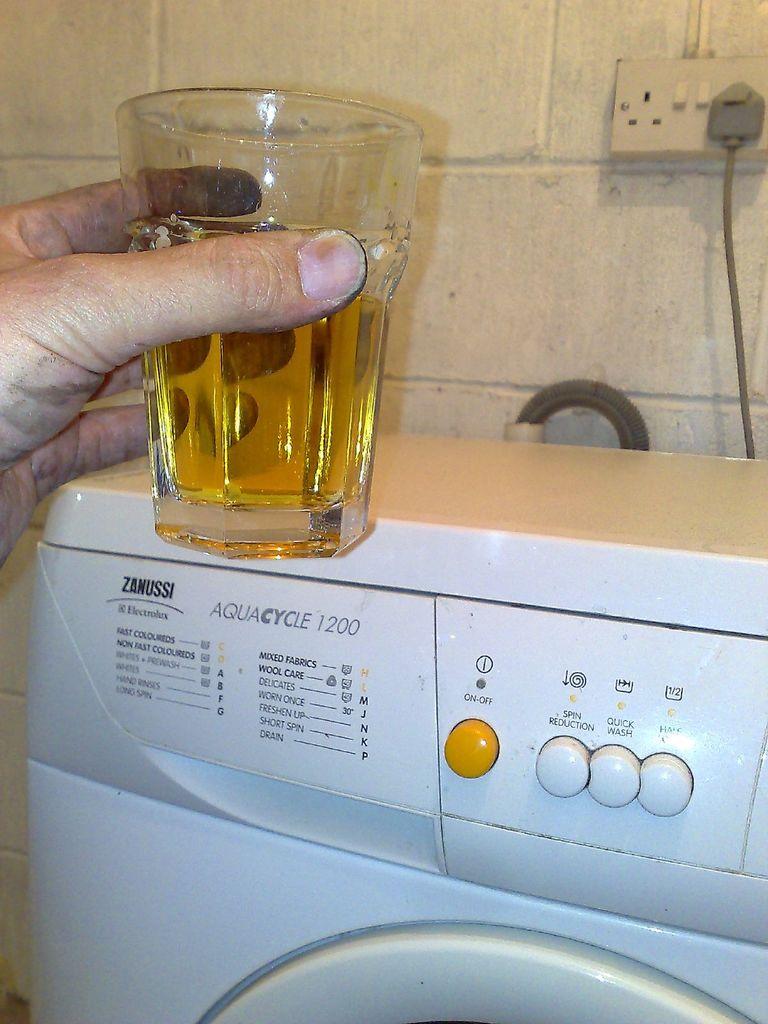What is the model number of this washer?
Give a very brief answer. 1200. What number is on the washer?
Keep it short and to the point. 1200. 